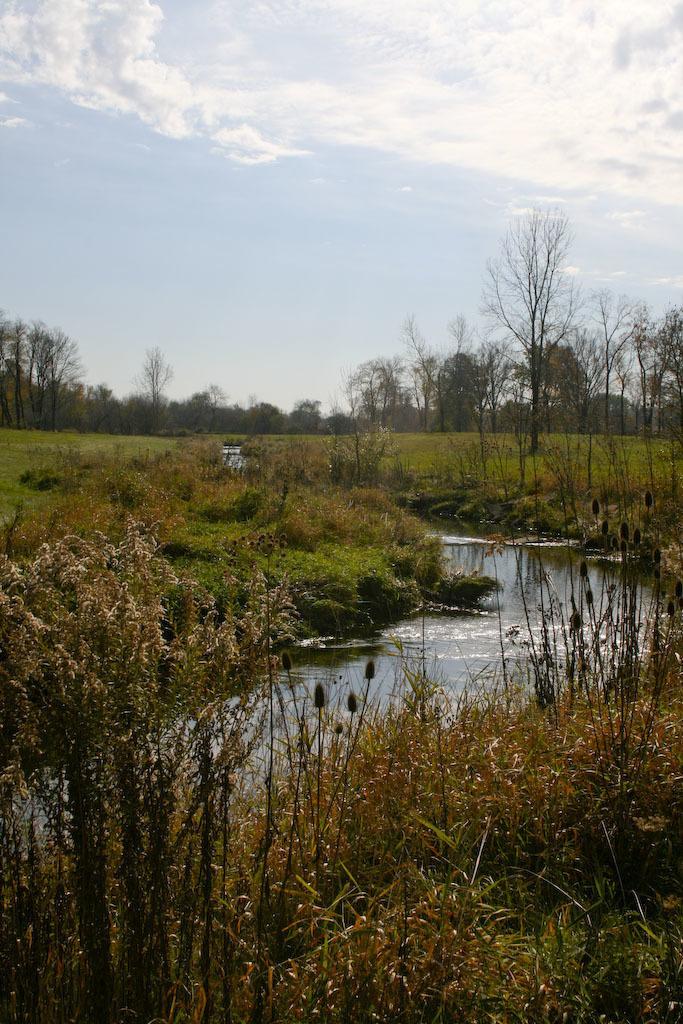Could you give a brief overview of what you see in this image? In this image, we can see some grass, plants. There are a few trees. We can see some water. We can see the sky with clouds. 